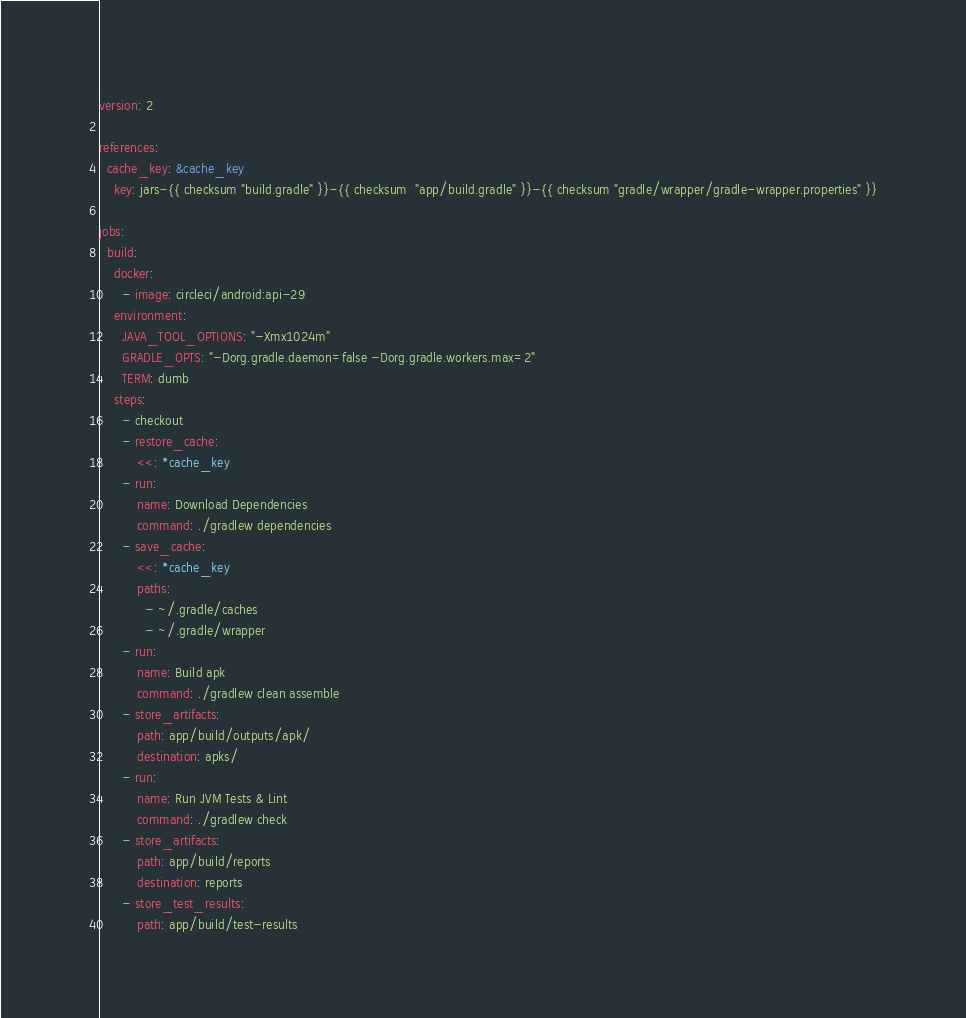Convert code to text. <code><loc_0><loc_0><loc_500><loc_500><_YAML_>version: 2

references:
  cache_key: &cache_key
    key: jars-{{ checksum "build.gradle" }}-{{ checksum  "app/build.gradle" }}-{{ checksum "gradle/wrapper/gradle-wrapper.properties" }}

jobs:
  build:
    docker:
      - image: circleci/android:api-29
    environment:
      JAVA_TOOL_OPTIONS: "-Xmx1024m"
      GRADLE_OPTS: "-Dorg.gradle.daemon=false -Dorg.gradle.workers.max=2"
      TERM: dumb
    steps:
      - checkout
      - restore_cache:
          <<: *cache_key
      - run:
          name: Download Dependencies
          command: ./gradlew dependencies
      - save_cache:
          <<: *cache_key
          paths:
            - ~/.gradle/caches
            - ~/.gradle/wrapper
      - run:
          name: Build apk
          command: ./gradlew clean assemble
      - store_artifacts:
          path: app/build/outputs/apk/
          destination: apks/
      - run:
          name: Run JVM Tests & Lint
          command: ./gradlew check
      - store_artifacts:
          path: app/build/reports
          destination: reports
      - store_test_results:
          path: app/build/test-results</code> 